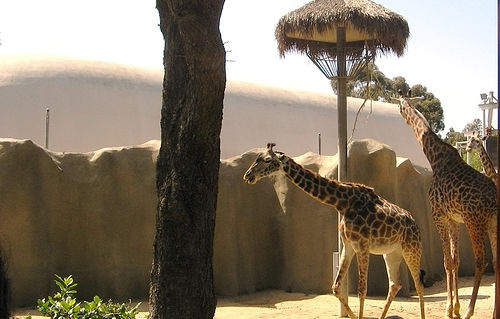Describe the objects in this image and their specific colors. I can see giraffe in white, black, maroon, and olive tones, giraffe in white, black, maroon, and brown tones, and giraffe in white, maroon, gray, and tan tones in this image. 